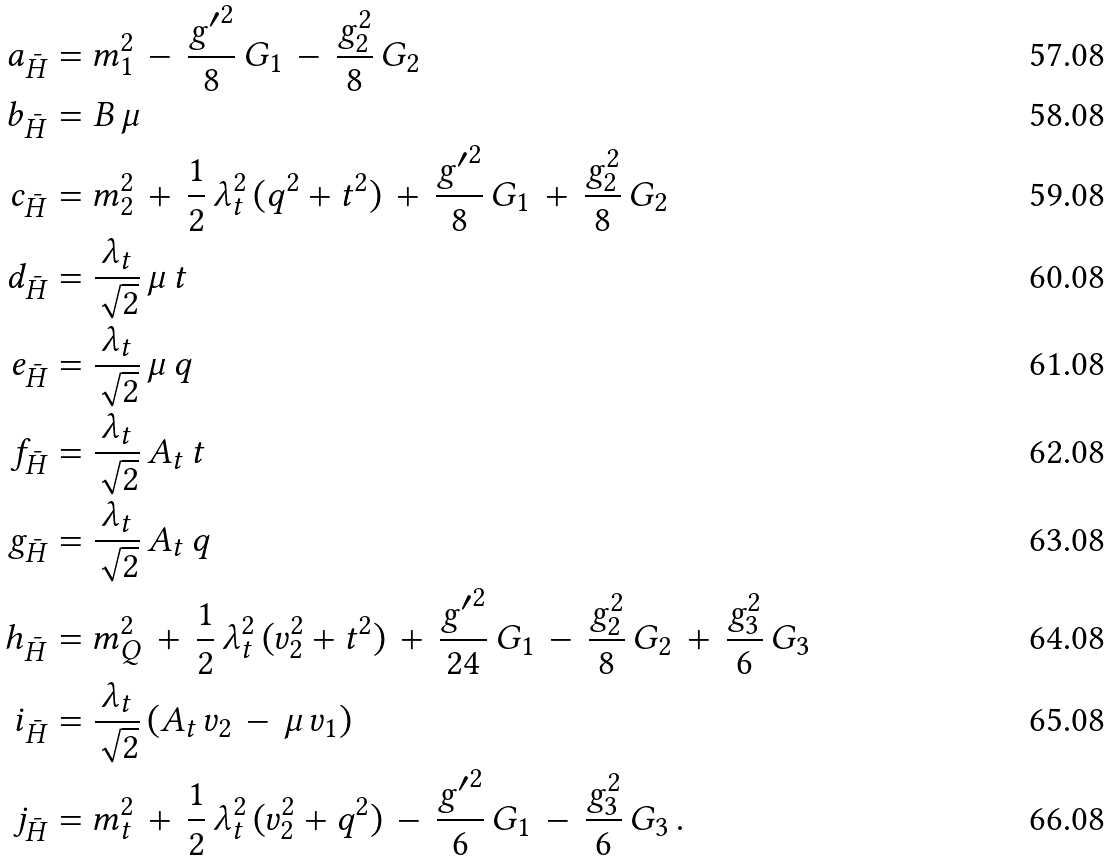Convert formula to latex. <formula><loc_0><loc_0><loc_500><loc_500>a _ { \bar { H } } & = m _ { 1 } ^ { 2 } \, - \, \frac { { g ^ { \prime } } ^ { 2 } } { 8 } \, G _ { 1 } \, - \, \frac { g _ { 2 } ^ { 2 } } { 8 } \, G _ { 2 } \\ b _ { \bar { H } } & = B \, \mu \\ c _ { \bar { H } } & = m _ { 2 } ^ { 2 } \, + \, \frac { 1 } { 2 } \, \lambda _ { t } ^ { 2 } \, ( q ^ { 2 } + t ^ { 2 } ) \, + \, \frac { { g ^ { \prime } } ^ { 2 } } { 8 } \, G _ { 1 } \, + \, \frac { g _ { 2 } ^ { 2 } } { 8 } \, G _ { 2 } \\ d _ { \bar { H } } & = \frac { \lambda _ { t } } { \sqrt { 2 } } \, \mu \, t \\ e _ { \bar { H } } & = \frac { \lambda _ { t } } { \sqrt { 2 } } \, \mu \, q \\ f _ { \bar { H } } & = \frac { \lambda _ { t } } { \sqrt { 2 } } \, A _ { t } \, t \\ g _ { \bar { H } } & = \frac { \lambda _ { t } } { \sqrt { 2 } } \, A _ { t } \, q \\ h _ { \bar { H } } & = m _ { Q } ^ { 2 } \, + \, \frac { 1 } { 2 } \, \lambda _ { t } ^ { 2 } \, ( v _ { 2 } ^ { 2 } + t ^ { 2 } ) \, + \, \frac { { g ^ { \prime } } ^ { 2 } } { 2 4 } \, G _ { 1 } \, - \, \frac { g _ { 2 } ^ { 2 } } { 8 } \, G _ { 2 } \, + \, \frac { g _ { 3 } ^ { 2 } } { 6 } \, G _ { 3 } \\ i _ { \bar { H } } & = \frac { \lambda _ { t } } { \sqrt { 2 } } \, ( A _ { t } \, v _ { 2 } \, - \, \mu \, v _ { 1 } ) \\ j _ { \bar { H } } & = m _ { t } ^ { 2 } \, + \, \frac { 1 } { 2 } \, \lambda _ { t } ^ { 2 } \, ( v _ { 2 } ^ { 2 } + q ^ { 2 } ) \, - \, \frac { { g ^ { \prime } } ^ { 2 } } { 6 } \, G _ { 1 } \, - \, \frac { g _ { 3 } ^ { 2 } } { 6 } \, G _ { 3 } \, .</formula> 